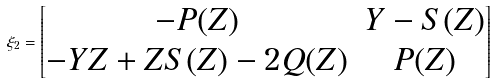<formula> <loc_0><loc_0><loc_500><loc_500>\xi _ { 2 } = \begin{bmatrix} - P ( Z ) & Y - S ( Z ) \\ - Y Z + Z S ( Z ) - 2 Q ( Z ) & P ( Z ) \\ \end{bmatrix}</formula> 